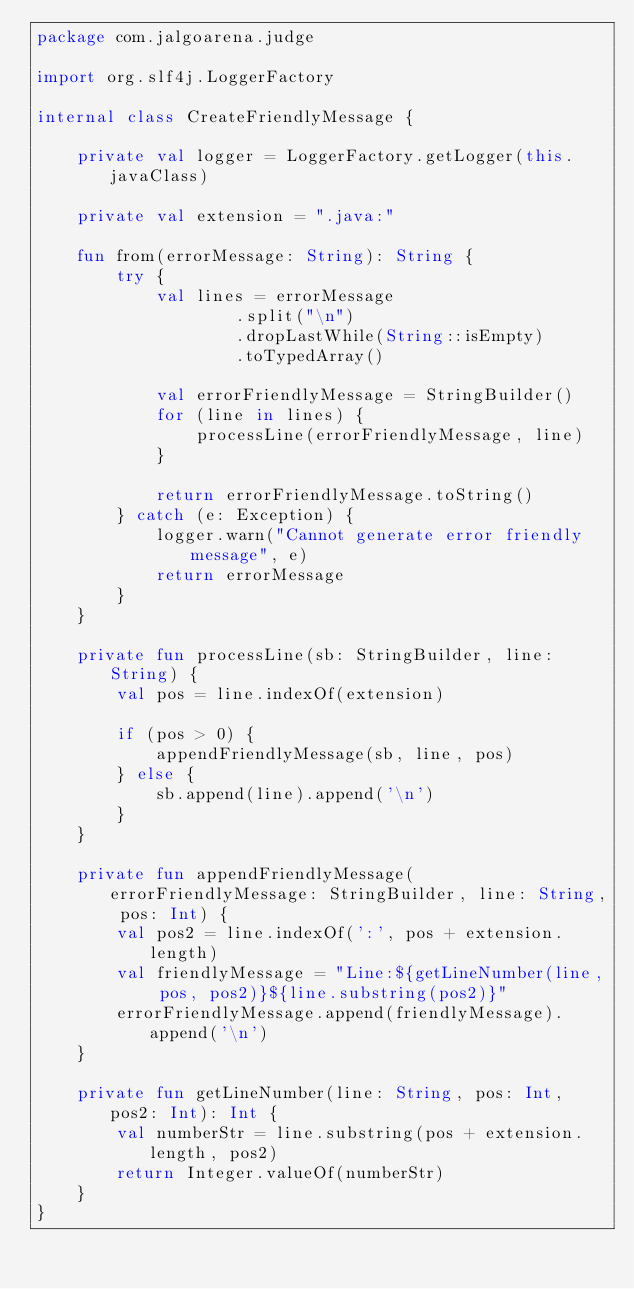<code> <loc_0><loc_0><loc_500><loc_500><_Kotlin_>package com.jalgoarena.judge

import org.slf4j.LoggerFactory

internal class CreateFriendlyMessage {

    private val logger = LoggerFactory.getLogger(this.javaClass)

    private val extension = ".java:"

    fun from(errorMessage: String): String {
        try {
            val lines = errorMessage
                    .split("\n")
                    .dropLastWhile(String::isEmpty)
                    .toTypedArray()

            val errorFriendlyMessage = StringBuilder()
            for (line in lines) {
                processLine(errorFriendlyMessage, line)
            }

            return errorFriendlyMessage.toString()
        } catch (e: Exception) {
            logger.warn("Cannot generate error friendly message", e)
            return errorMessage
        }
    }

    private fun processLine(sb: StringBuilder, line: String) {
        val pos = line.indexOf(extension)

        if (pos > 0) {
            appendFriendlyMessage(sb, line, pos)
        } else {
            sb.append(line).append('\n')
        }
    }

    private fun appendFriendlyMessage(errorFriendlyMessage: StringBuilder, line: String, pos: Int) {
        val pos2 = line.indexOf(':', pos + extension.length)
        val friendlyMessage = "Line:${getLineNumber(line, pos, pos2)}${line.substring(pos2)}"
        errorFriendlyMessage.append(friendlyMessage).append('\n')
    }

    private fun getLineNumber(line: String, pos: Int, pos2: Int): Int {
        val numberStr = line.substring(pos + extension.length, pos2)
        return Integer.valueOf(numberStr)
    }
}
</code> 